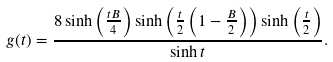Convert formula to latex. <formula><loc_0><loc_0><loc_500><loc_500>g ( t ) = \frac { 8 \sinh \left ( \frac { t B } { 4 } \right ) \sinh \left ( \frac { t } { 2 } \left ( 1 - \frac { B } { 2 } \right ) \right ) \sinh \left ( \frac { t } { 2 } \right ) } { \sinh t } .</formula> 